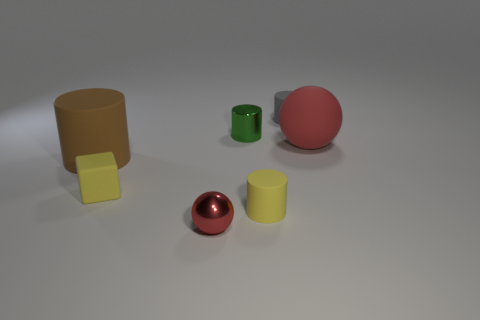Subtract all red spheres. How many were subtracted if there are1red spheres left? 1 Add 1 big rubber balls. How many objects exist? 8 Subtract all balls. How many objects are left? 5 Subtract 0 green balls. How many objects are left? 7 Subtract all matte cylinders. Subtract all tiny yellow rubber objects. How many objects are left? 2 Add 7 metal balls. How many metal balls are left? 8 Add 7 tiny shiny balls. How many tiny shiny balls exist? 8 